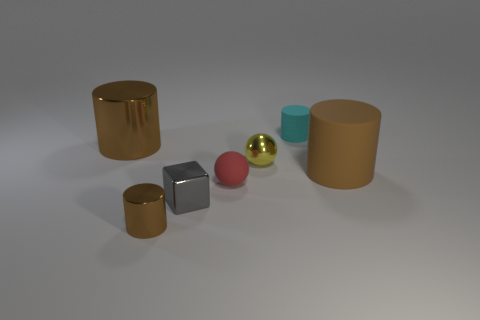Subtract all purple blocks. How many brown cylinders are left? 3 Add 1 small rubber cylinders. How many objects exist? 8 Subtract all cylinders. How many objects are left? 3 Add 5 cyan metal objects. How many cyan metal objects exist? 5 Subtract 0 purple cubes. How many objects are left? 7 Subtract all brown matte cylinders. Subtract all tiny blocks. How many objects are left? 5 Add 5 tiny matte cylinders. How many tiny matte cylinders are left? 6 